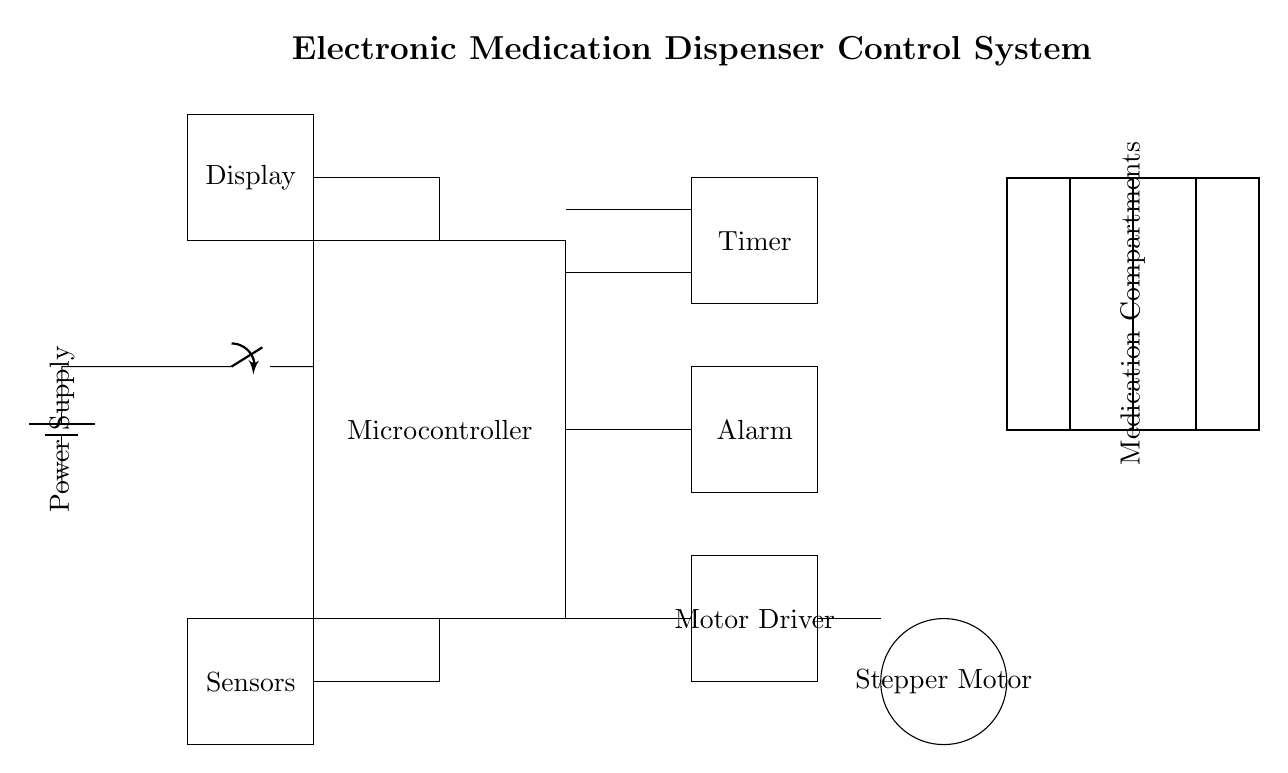What is the main control unit of the circuit? The main control unit is the Microcontroller, which coordinates all operations in the system.
Answer: Microcontroller How many medication compartments are there? There are four medication compartments shown in the diagram, divided into sections.
Answer: Four What component is responsible for issuing alerts? The component responsible for issuing alerts is the Alarm, which signals when medication dispensing is due.
Answer: Alarm What type of motor is used in this circuit? The type of motor used in this circuit is a Stepper Motor, which provides precise control for dispensing medication.
Answer: Stepper Motor Which component powers the entire system? The Power Supply is the component that powers the entire system, providing the necessary voltage and current.
Answer: Power Supply How does the Timer interact with the Microcontroller? The Timer sends timing signals to the Microcontroller, allowing it to schedule medication dispensing accurately.
Answer: Sends timing signals What is the function of the Sensors in this circuit? The Sensors monitor the medication compartments to detect if medication has been dispensed or is present.
Answer: Monitor medication compartments 